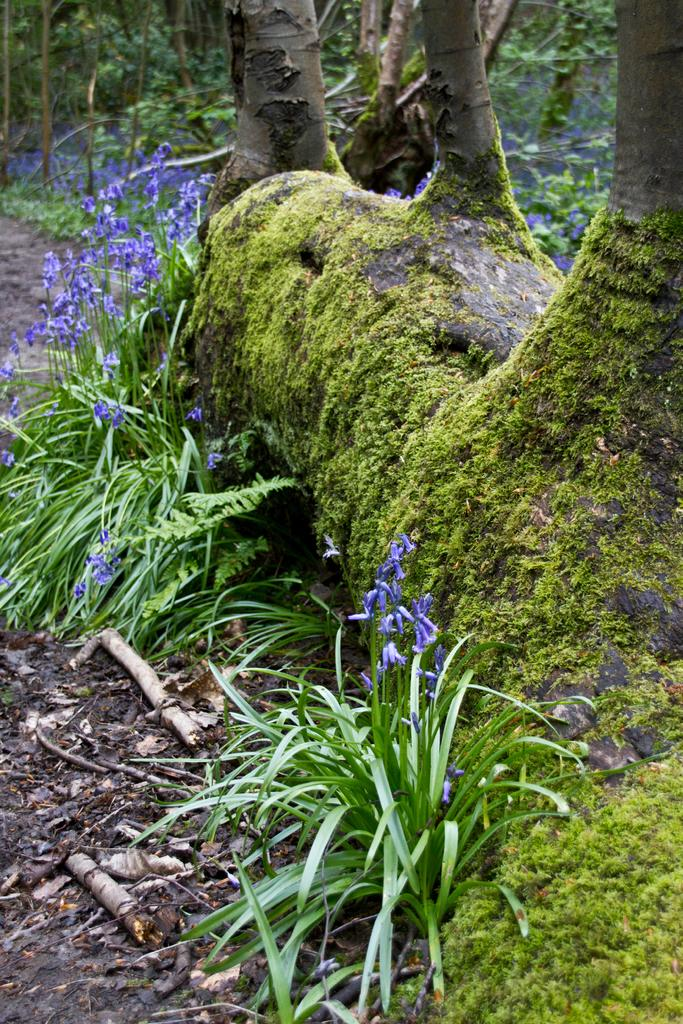What is the main subject of the image? The main subject of the image is a tree trunk with algae. Are there any other trees visible in the image? Yes, there are trees in the image. What type of plants can be seen in the image besides trees? There are plants with flowers in the image. What type of cakes are being served at the birthday party in the image? There is no birthday party or cakes present in the image; it features a tree trunk with algae and other plants. 